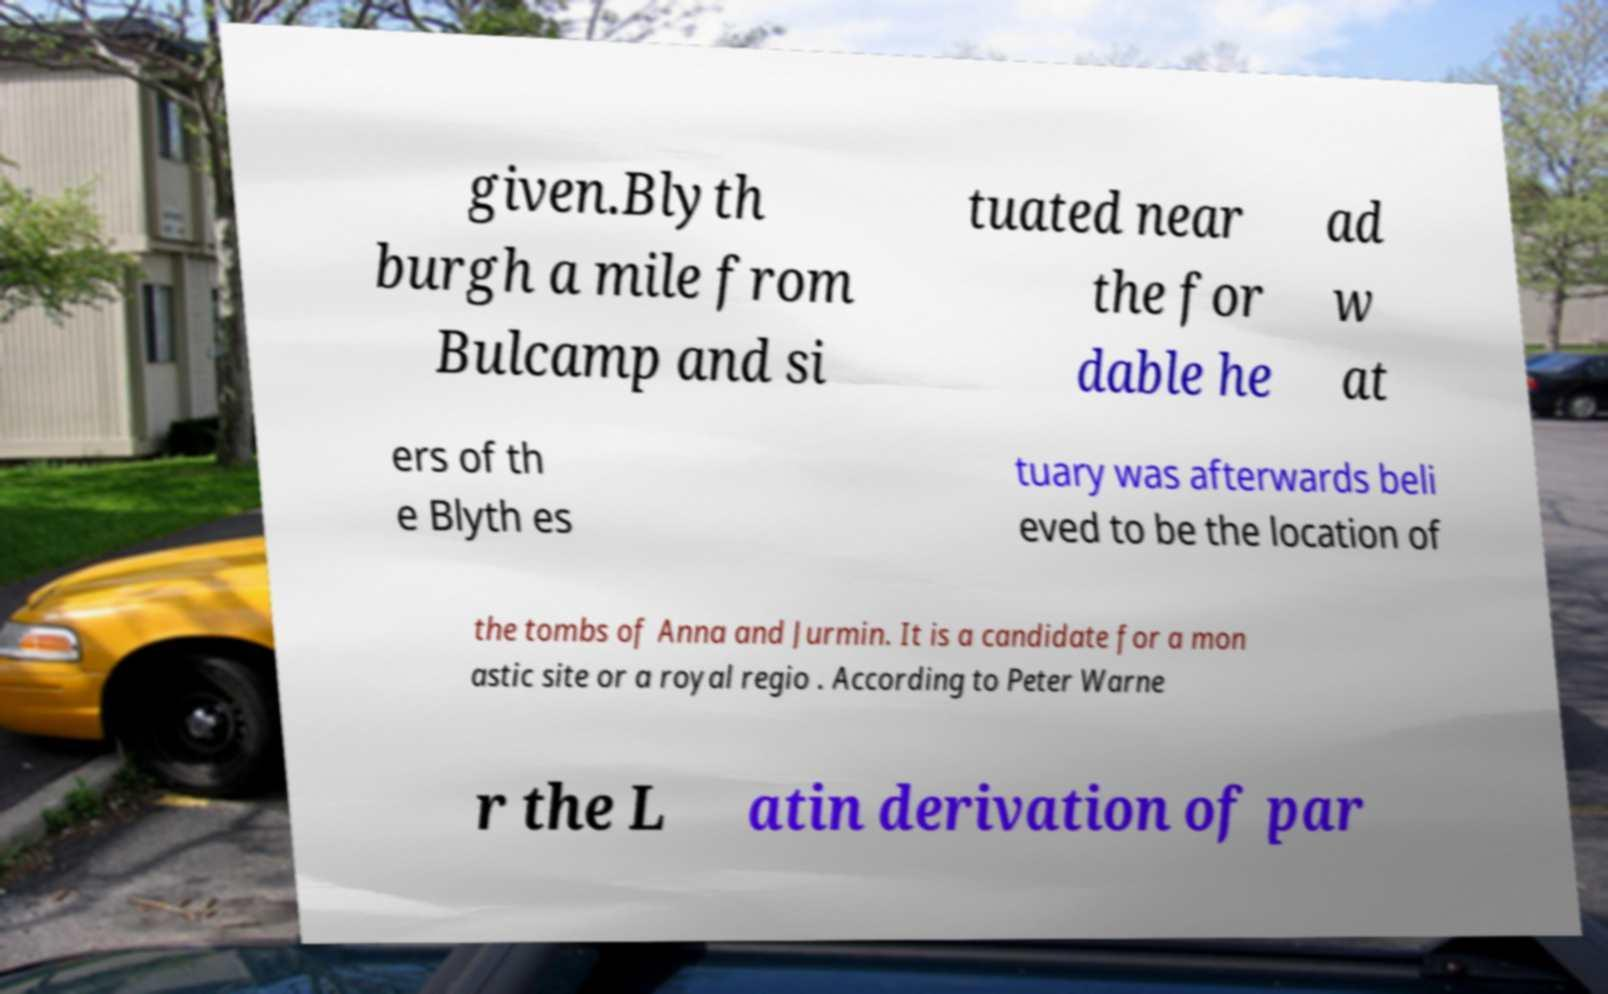Can you accurately transcribe the text from the provided image for me? given.Blyth burgh a mile from Bulcamp and si tuated near the for dable he ad w at ers of th e Blyth es tuary was afterwards beli eved to be the location of the tombs of Anna and Jurmin. It is a candidate for a mon astic site or a royal regio . According to Peter Warne r the L atin derivation of par 